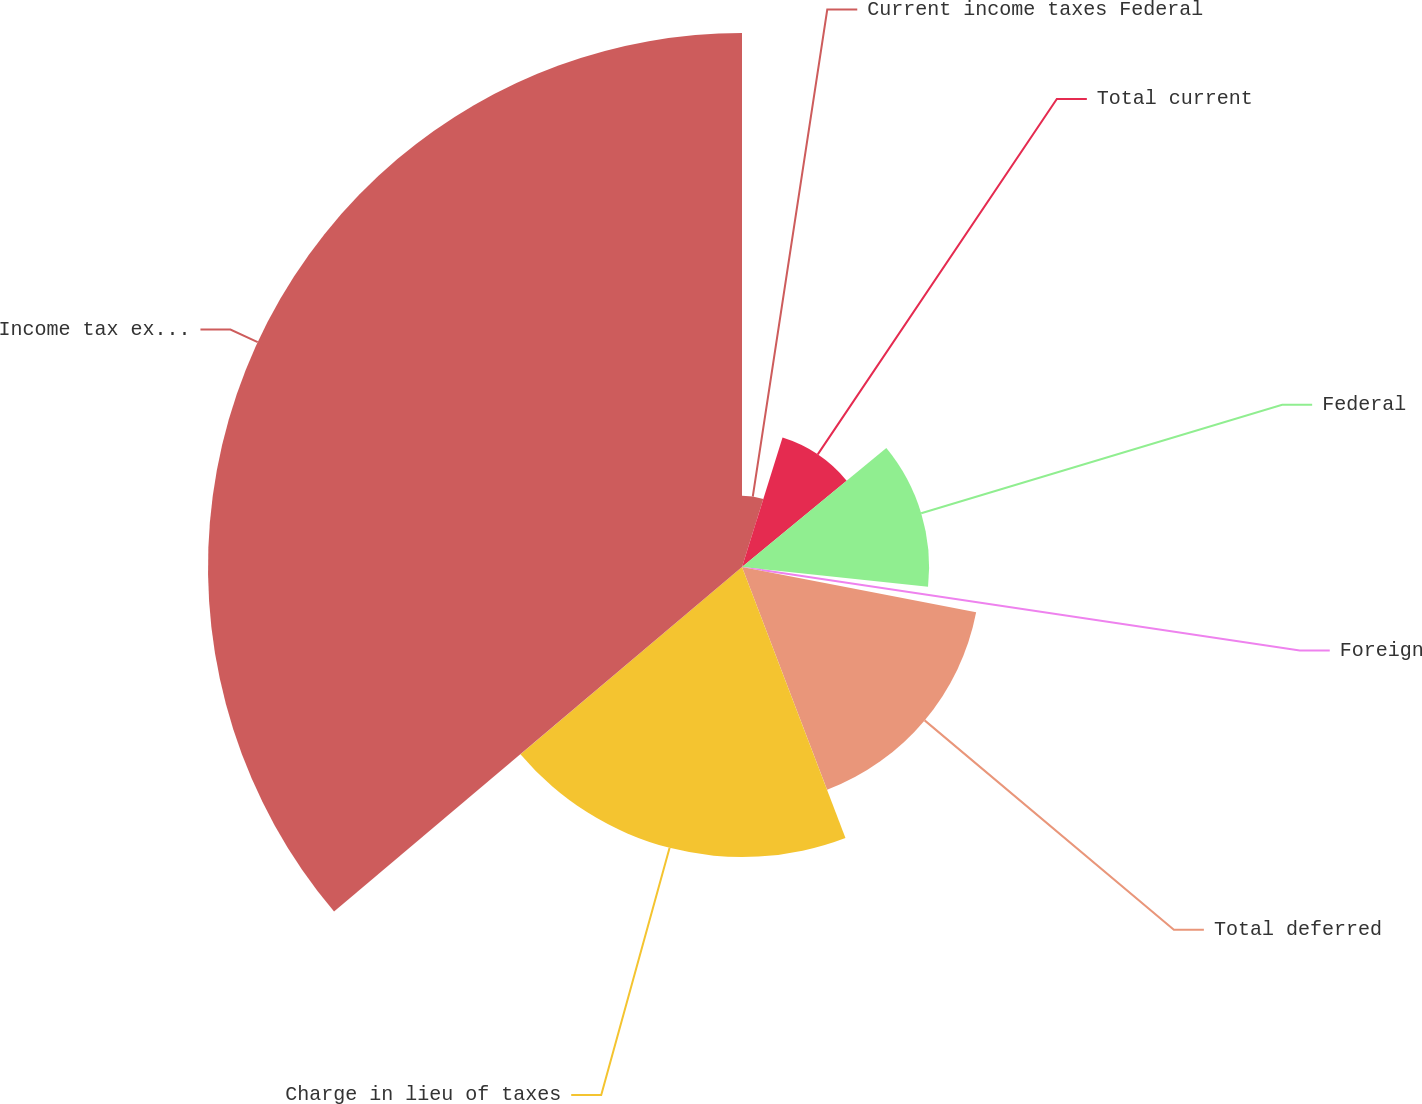Convert chart. <chart><loc_0><loc_0><loc_500><loc_500><pie_chart><fcel>Current income taxes Federal<fcel>Total current<fcel>Federal<fcel>Foreign<fcel>Total deferred<fcel>Charge in lieu of taxes<fcel>Income tax expense<nl><fcel>4.83%<fcel>9.19%<fcel>12.67%<fcel>1.35%<fcel>16.15%<fcel>19.64%<fcel>36.16%<nl></chart> 